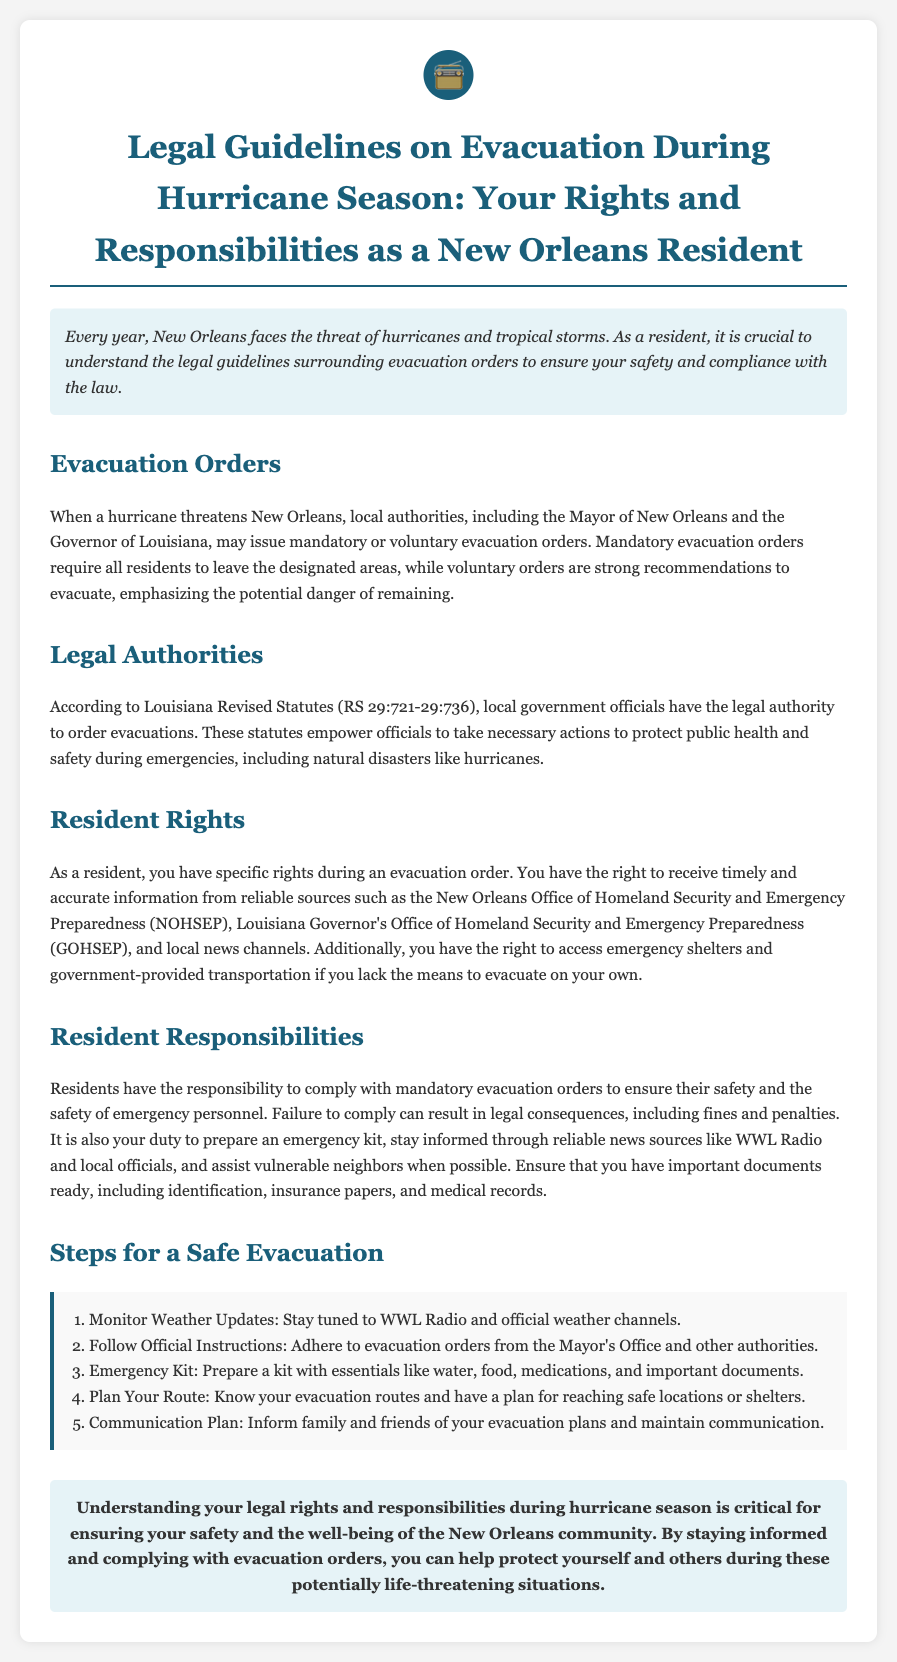What are the two types of evacuation orders? The document lists mandatory and voluntary evacuation orders as the two types.
Answer: Mandatory and voluntary Who issues evacuation orders in New Orleans? The document states that local authorities, including the Mayor and Governor, issue evacuation orders.
Answer: Local authorities What are residents required to do during a mandatory evacuation? The text emphasizes that residents must comply with mandatory evacuation orders for safety.
Answer: Comply What is one right of residents during an evacuation order? The document mentions that residents have the right to receive timely and accurate information.
Answer: Receive information What legal statutes empower officials to order evacuations? According to the document, Louisiana Revised Statutes (RS 29:721-29:736) empower officials to order evacuations.
Answer: RS 29:721-29:736 What is the first step for a safe evacuation? The document identifies that monitoring weather updates is the first step.
Answer: Monitor Weather Updates How should residents stay informed during an evacuation? The text suggests that residents should stay informed through reliable news sources like WWL Radio.
Answer: WWL Radio What can happen if residents fail to comply with evacuation orders? The document indicates that failure to comply can lead to legal consequences, including fines.
Answer: Fines What type of document is this? The information outlines legal guidelines specific to evacuation during hurricane season for residents.
Answer: Legal brief 